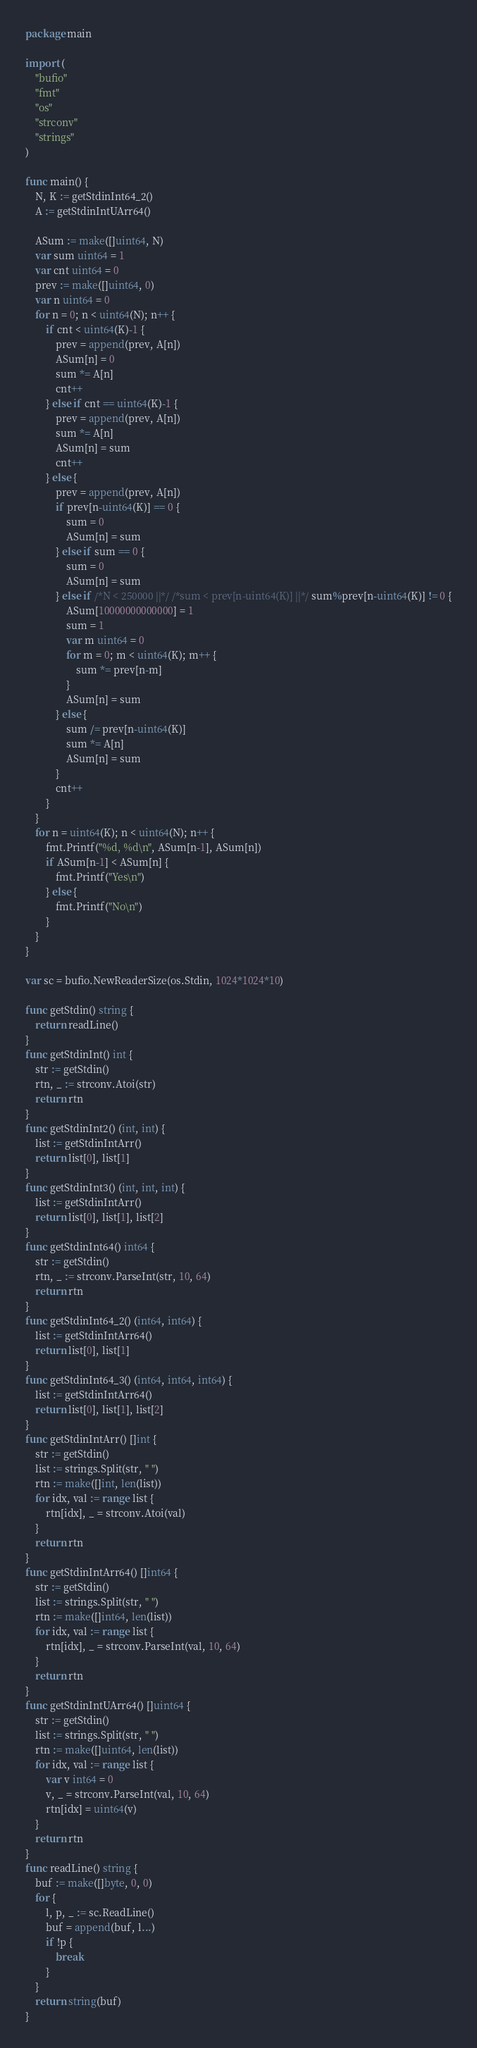<code> <loc_0><loc_0><loc_500><loc_500><_Go_>package main

import (
	"bufio"
	"fmt"
	"os"
	"strconv"
	"strings"
)

func main() {
	N, K := getStdinInt64_2()
	A := getStdinIntUArr64()

	ASum := make([]uint64, N)
	var sum uint64 = 1
	var cnt uint64 = 0
	prev := make([]uint64, 0)
	var n uint64 = 0
	for n = 0; n < uint64(N); n++ {
		if cnt < uint64(K)-1 {
			prev = append(prev, A[n])
			ASum[n] = 0
			sum *= A[n]
			cnt++
		} else if cnt == uint64(K)-1 {
			prev = append(prev, A[n])
			sum *= A[n]
			ASum[n] = sum
			cnt++
		} else {
			prev = append(prev, A[n])
			if prev[n-uint64(K)] == 0 {
				sum = 0
				ASum[n] = sum
			} else if sum == 0 {
				sum = 0
				ASum[n] = sum
			} else if /*N < 250000 ||*/ /*sum < prev[n-uint64(K)] ||*/ sum%prev[n-uint64(K)] != 0 {
				ASum[10000000000000] = 1
				sum = 1
				var m uint64 = 0
				for m = 0; m < uint64(K); m++ {
					sum *= prev[n-m]
				}
				ASum[n] = sum
			} else {
				sum /= prev[n-uint64(K)]
				sum *= A[n]
				ASum[n] = sum
			}
			cnt++
		}
	}
	for n = uint64(K); n < uint64(N); n++ {
		fmt.Printf("%d, %d\n", ASum[n-1], ASum[n])
		if ASum[n-1] < ASum[n] {
			fmt.Printf("Yes\n")
		} else {
			fmt.Printf("No\n")
		}
	}
}

var sc = bufio.NewReaderSize(os.Stdin, 1024*1024*10)

func getStdin() string {
	return readLine()
}
func getStdinInt() int {
	str := getStdin()
	rtn, _ := strconv.Atoi(str)
	return rtn
}
func getStdinInt2() (int, int) {
	list := getStdinIntArr()
	return list[0], list[1]
}
func getStdinInt3() (int, int, int) {
	list := getStdinIntArr()
	return list[0], list[1], list[2]
}
func getStdinInt64() int64 {
	str := getStdin()
	rtn, _ := strconv.ParseInt(str, 10, 64)
	return rtn
}
func getStdinInt64_2() (int64, int64) {
	list := getStdinIntArr64()
	return list[0], list[1]
}
func getStdinInt64_3() (int64, int64, int64) {
	list := getStdinIntArr64()
	return list[0], list[1], list[2]
}
func getStdinIntArr() []int {
	str := getStdin()
	list := strings.Split(str, " ")
	rtn := make([]int, len(list))
	for idx, val := range list {
		rtn[idx], _ = strconv.Atoi(val)
	}
	return rtn
}
func getStdinIntArr64() []int64 {
	str := getStdin()
	list := strings.Split(str, " ")
	rtn := make([]int64, len(list))
	for idx, val := range list {
		rtn[idx], _ = strconv.ParseInt(val, 10, 64)
	}
	return rtn
}
func getStdinIntUArr64() []uint64 {
	str := getStdin()
	list := strings.Split(str, " ")
	rtn := make([]uint64, len(list))
	for idx, val := range list {
		var v int64 = 0
		v, _ = strconv.ParseInt(val, 10, 64)
		rtn[idx] = uint64(v)
	}
	return rtn
}
func readLine() string {
	buf := make([]byte, 0, 0)
	for {
		l, p, _ := sc.ReadLine()
		buf = append(buf, l...)
		if !p {
			break
		}
	}
	return string(buf)
}
</code> 